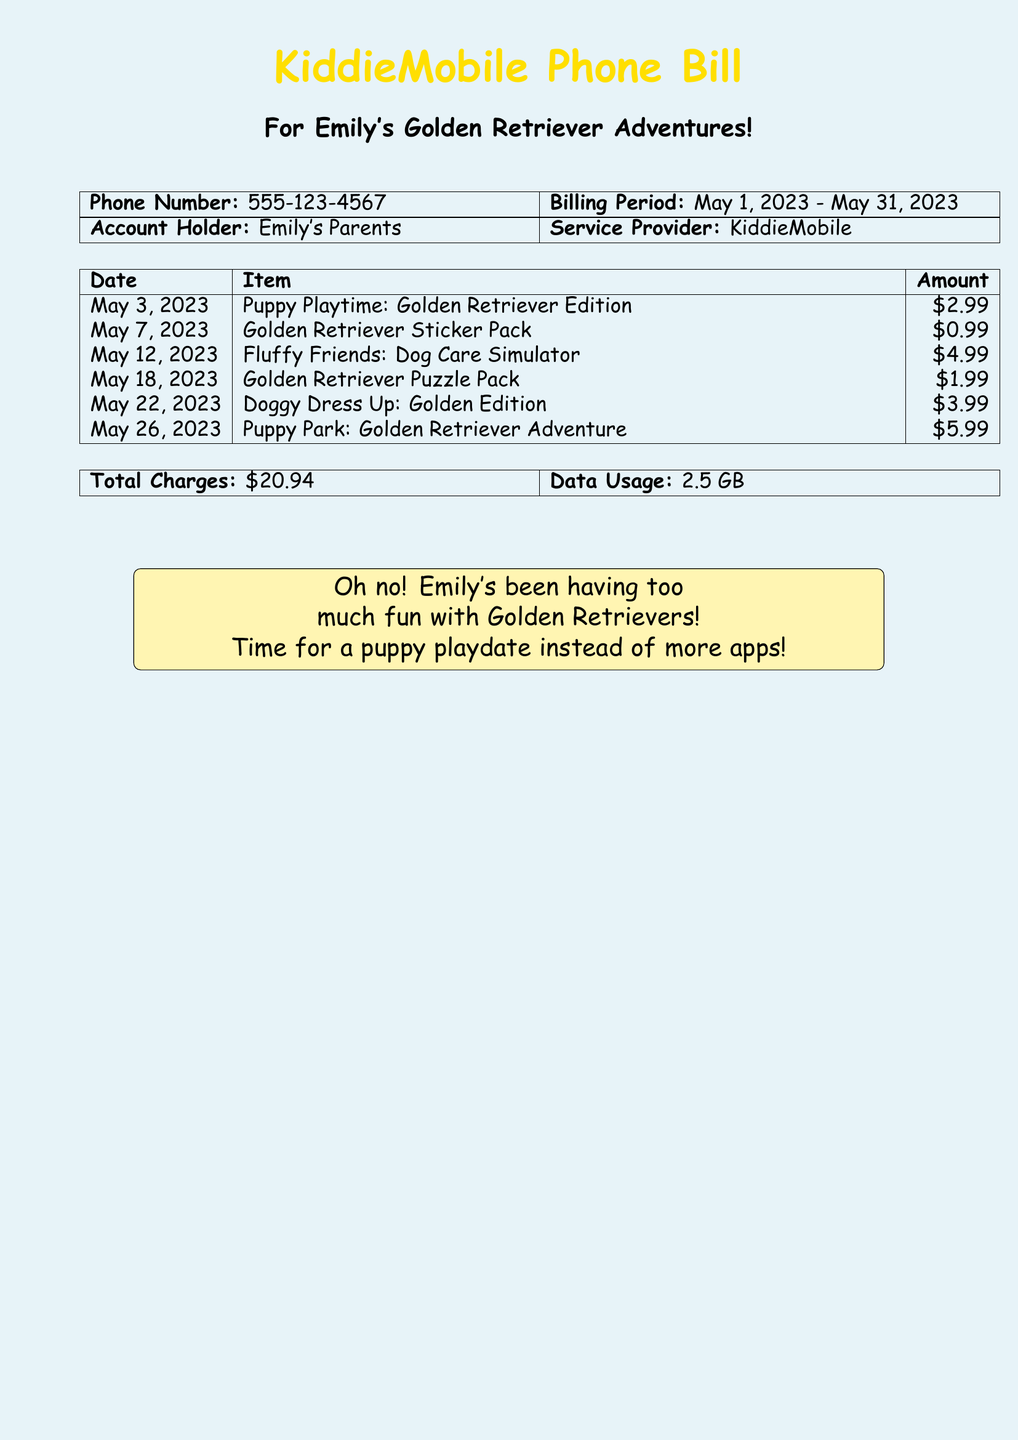What is the phone number listed? The phone number is clearly stated in the document, which is important for identifying the account holder's contact information.
Answer: 555-123-4567 What is the total amount charged? The total charges are summarized at the bottom of the charge list, representing the cumulative costs.
Answer: $20.94 How many apps were downloaded? Each entry in the list represents an app that was downloaded, so counting the entries gives the total number of apps.
Answer: 6 What is the most expensive item? By reviewing the list, the highest charge indicates the cost of the app that cost the most.
Answer: $5.99 What is the billing period? The billing period provides a timeframe for when the charges were incurred, and it is mentioned explicitly in the document.
Answer: May 1, 2023 - May 31, 2023 Which app is related to dog care? Looking through the list, we identify the app specifically about dog care and its relation to the Golden Retriever theme.
Answer: Fluffy Friends: Dog Care Simulator What was the date of the first charge? The first entry in the list shows the earliest transaction date for the Golden Retriever-themed apps.
Answer: May 3, 2023 What is the data usage recorded? Data usage metrics are provided in the summary of the phone bill, indicating how much data was consumed during the billing period.
Answer: 2.5 GB What is the name of the service provider? The service provider's name is specified in the document and indicates the company handling the phone bill.
Answer: KiddieMobile 